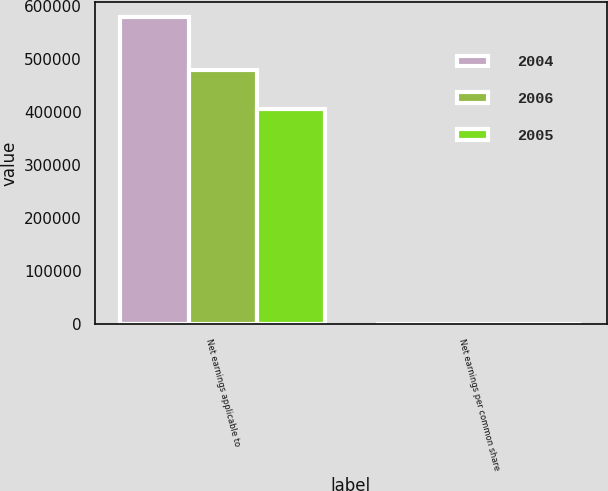Convert chart to OTSL. <chart><loc_0><loc_0><loc_500><loc_500><stacked_bar_chart><ecel><fcel>Net earnings applicable to<fcel>Net earnings per common share<nl><fcel>2004<fcel>579290<fcel>5.46<nl><fcel>2006<fcel>480121<fcel>5.27<nl><fcel>2005<fcel>405987<fcel>4.53<nl></chart> 